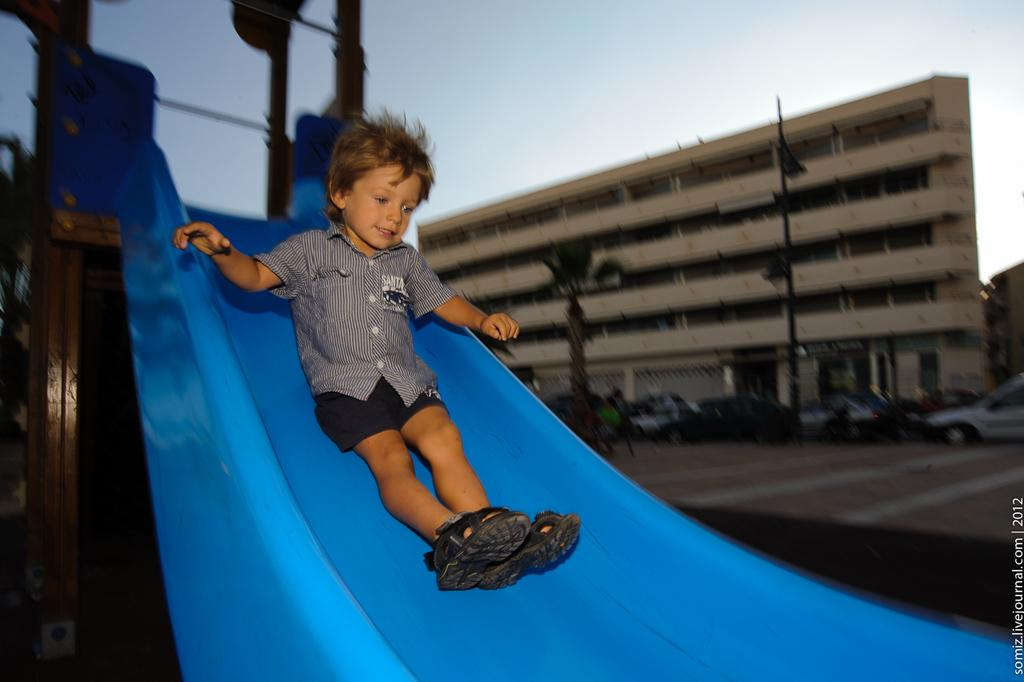What is the kid doing in the image? The kid is on a slider in the image. What type of vegetation can be seen in the image? There are trees and plants in the image. What structure is present in the image? There is a pole in the image. What type of man-made structures are visible in the image? There are buildings in the image. What else can be seen moving in the image? There are vehicles in the image. What part of the natural environment is visible in the image? The sky and the ground are visible in the image. What year is the carpenter mentioned in the image? There is no mention of a carpenter or a specific year in the image. 